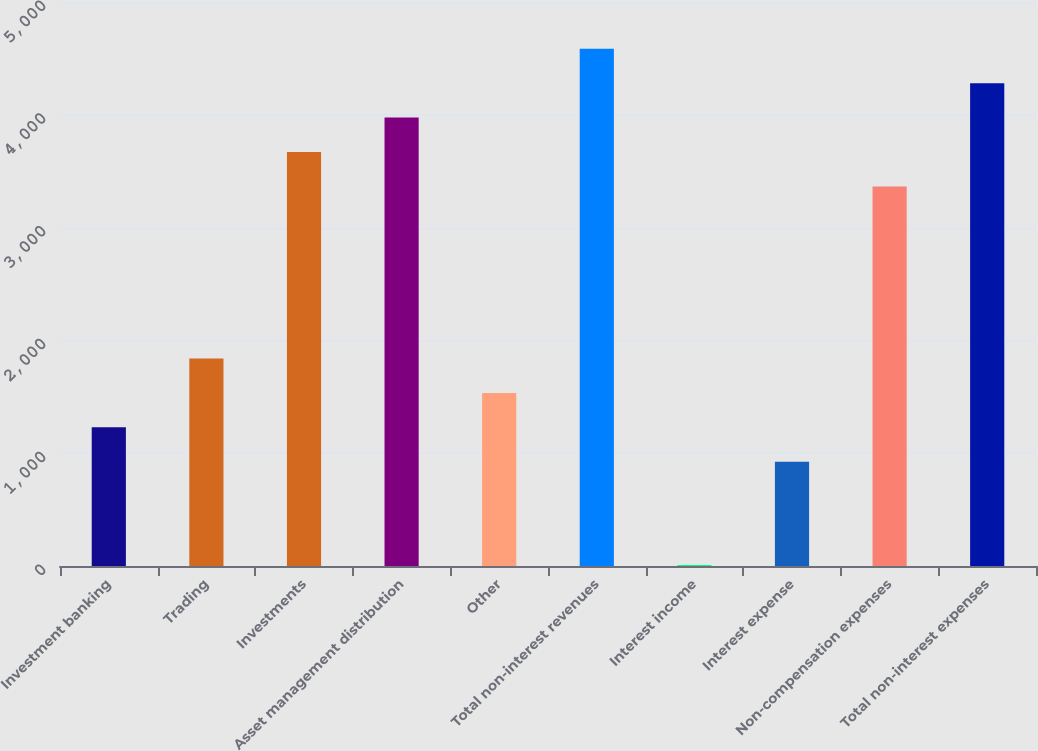Convert chart. <chart><loc_0><loc_0><loc_500><loc_500><bar_chart><fcel>Investment banking<fcel>Trading<fcel>Investments<fcel>Asset management distribution<fcel>Other<fcel>Total non-interest revenues<fcel>Interest income<fcel>Interest expense<fcel>Non-compensation expenses<fcel>Total non-interest expenses<nl><fcel>1229.4<fcel>1839.6<fcel>3670.2<fcel>3975.3<fcel>1534.5<fcel>4585.5<fcel>9<fcel>924.3<fcel>3365.1<fcel>4280.4<nl></chart> 